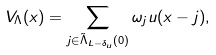<formula> <loc_0><loc_0><loc_500><loc_500>V _ { \Lambda } ( x ) = \sum _ { j \in \tilde { \Lambda } _ { L - \delta _ { u } } ( 0 ) } \omega _ { j } u ( x - j ) ,</formula> 